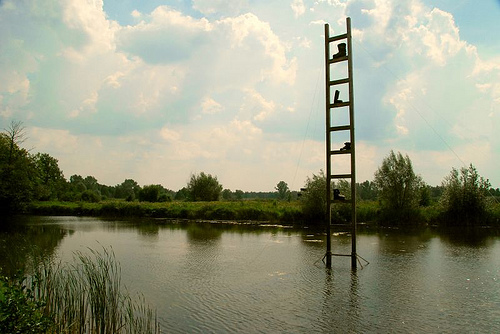<image>
Is the boot in front of the boot? No. The boot is not in front of the boot. The spatial positioning shows a different relationship between these objects. 